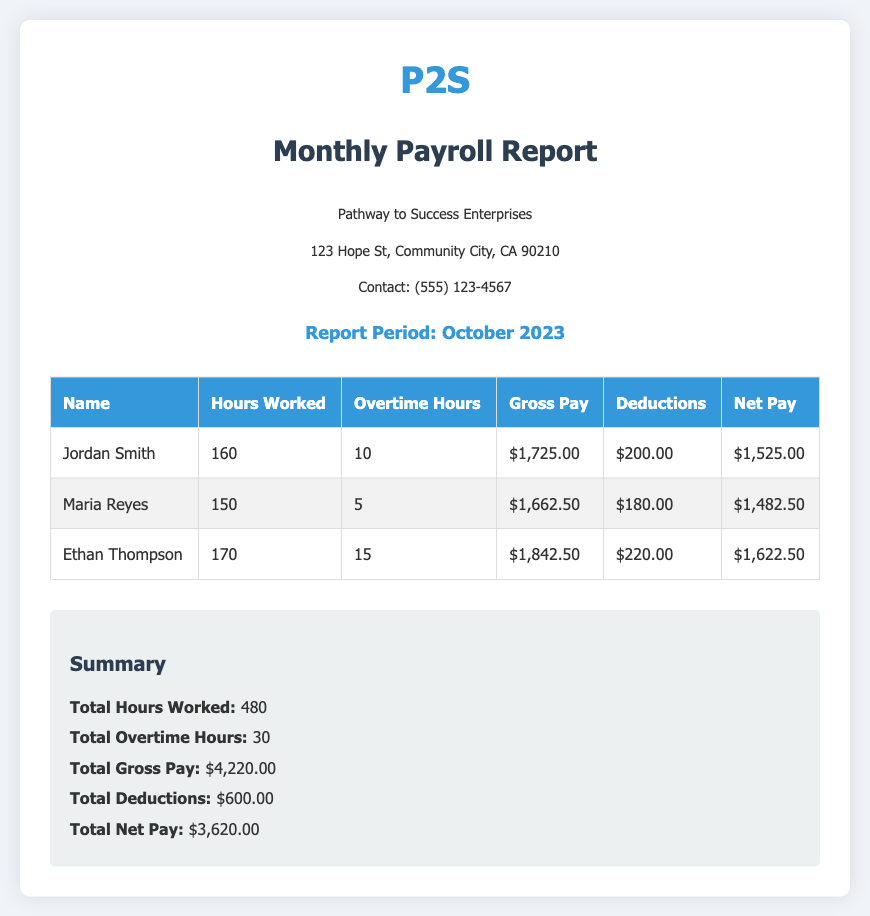What is the report period? The report period is specified in the document and is for October 2023.
Answer: October 2023 Who is the first apprentice listed in the report? The first apprentice mentioned in the report is Jordan Smith.
Answer: Jordan Smith What is the total net pay for all apprentices? Total net pay is the sum of the net pay for each apprentice listed in the document: $1,525.00 + $1,482.50 + $1,622.50 = $3,620.00.
Answer: $3,620.00 How many overtime hours did Ethan Thompson work? The document states that Ethan Thompson worked 15 overtime hours.
Answer: 15 What is the deduction amount for Maria Reyes? The deduction amount for Maria Reyes is specified in the table and is $180.00.
Answer: $180.00 What is the total gross pay listed? The total gross pay is the sum of the gross pay of all apprentices: $1,725.00 + $1,662.50 + $1,842.50 = $4,220.00.
Answer: $4,220.00 What is the total number of hours worked by all apprentices combined? The document provides a summary with the total hours worked, which equals 480 hours.
Answer: 480 What is the name of the business? The business name appears at the top of the document as Pathway to Success Enterprises.
Answer: Pathway to Success Enterprises How many total deductions were reported? The total deductions can be found in the summary section of the document, which lists $600.00.
Answer: $600.00 